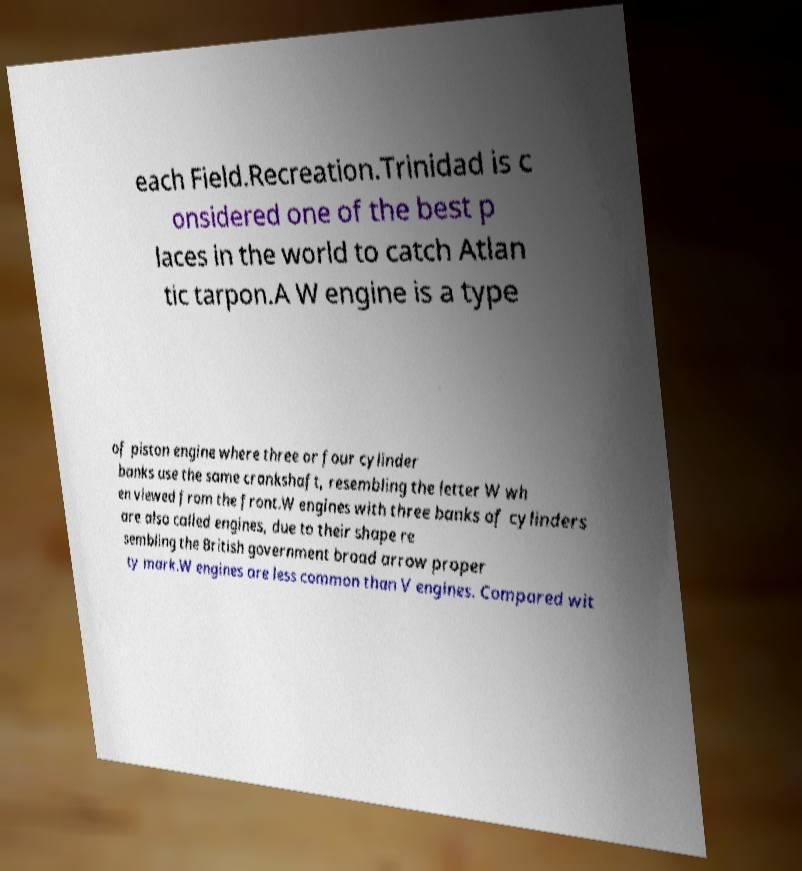For documentation purposes, I need the text within this image transcribed. Could you provide that? each Field.Recreation.Trinidad is c onsidered one of the best p laces in the world to catch Atlan tic tarpon.A W engine is a type of piston engine where three or four cylinder banks use the same crankshaft, resembling the letter W wh en viewed from the front.W engines with three banks of cylinders are also called engines, due to their shape re sembling the British government broad arrow proper ty mark.W engines are less common than V engines. Compared wit 